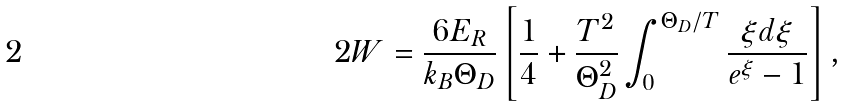<formula> <loc_0><loc_0><loc_500><loc_500>2 W = \frac { 6 E _ { R } } { k _ { B } \Theta _ { D } } \left [ \frac { 1 } { 4 } + \frac { T ^ { 2 } } { \Theta _ { D } ^ { 2 } } \int _ { 0 } ^ { \Theta _ { D } / T } \frac { \xi d \xi } { e ^ { \xi } - 1 } \right ] ,</formula> 